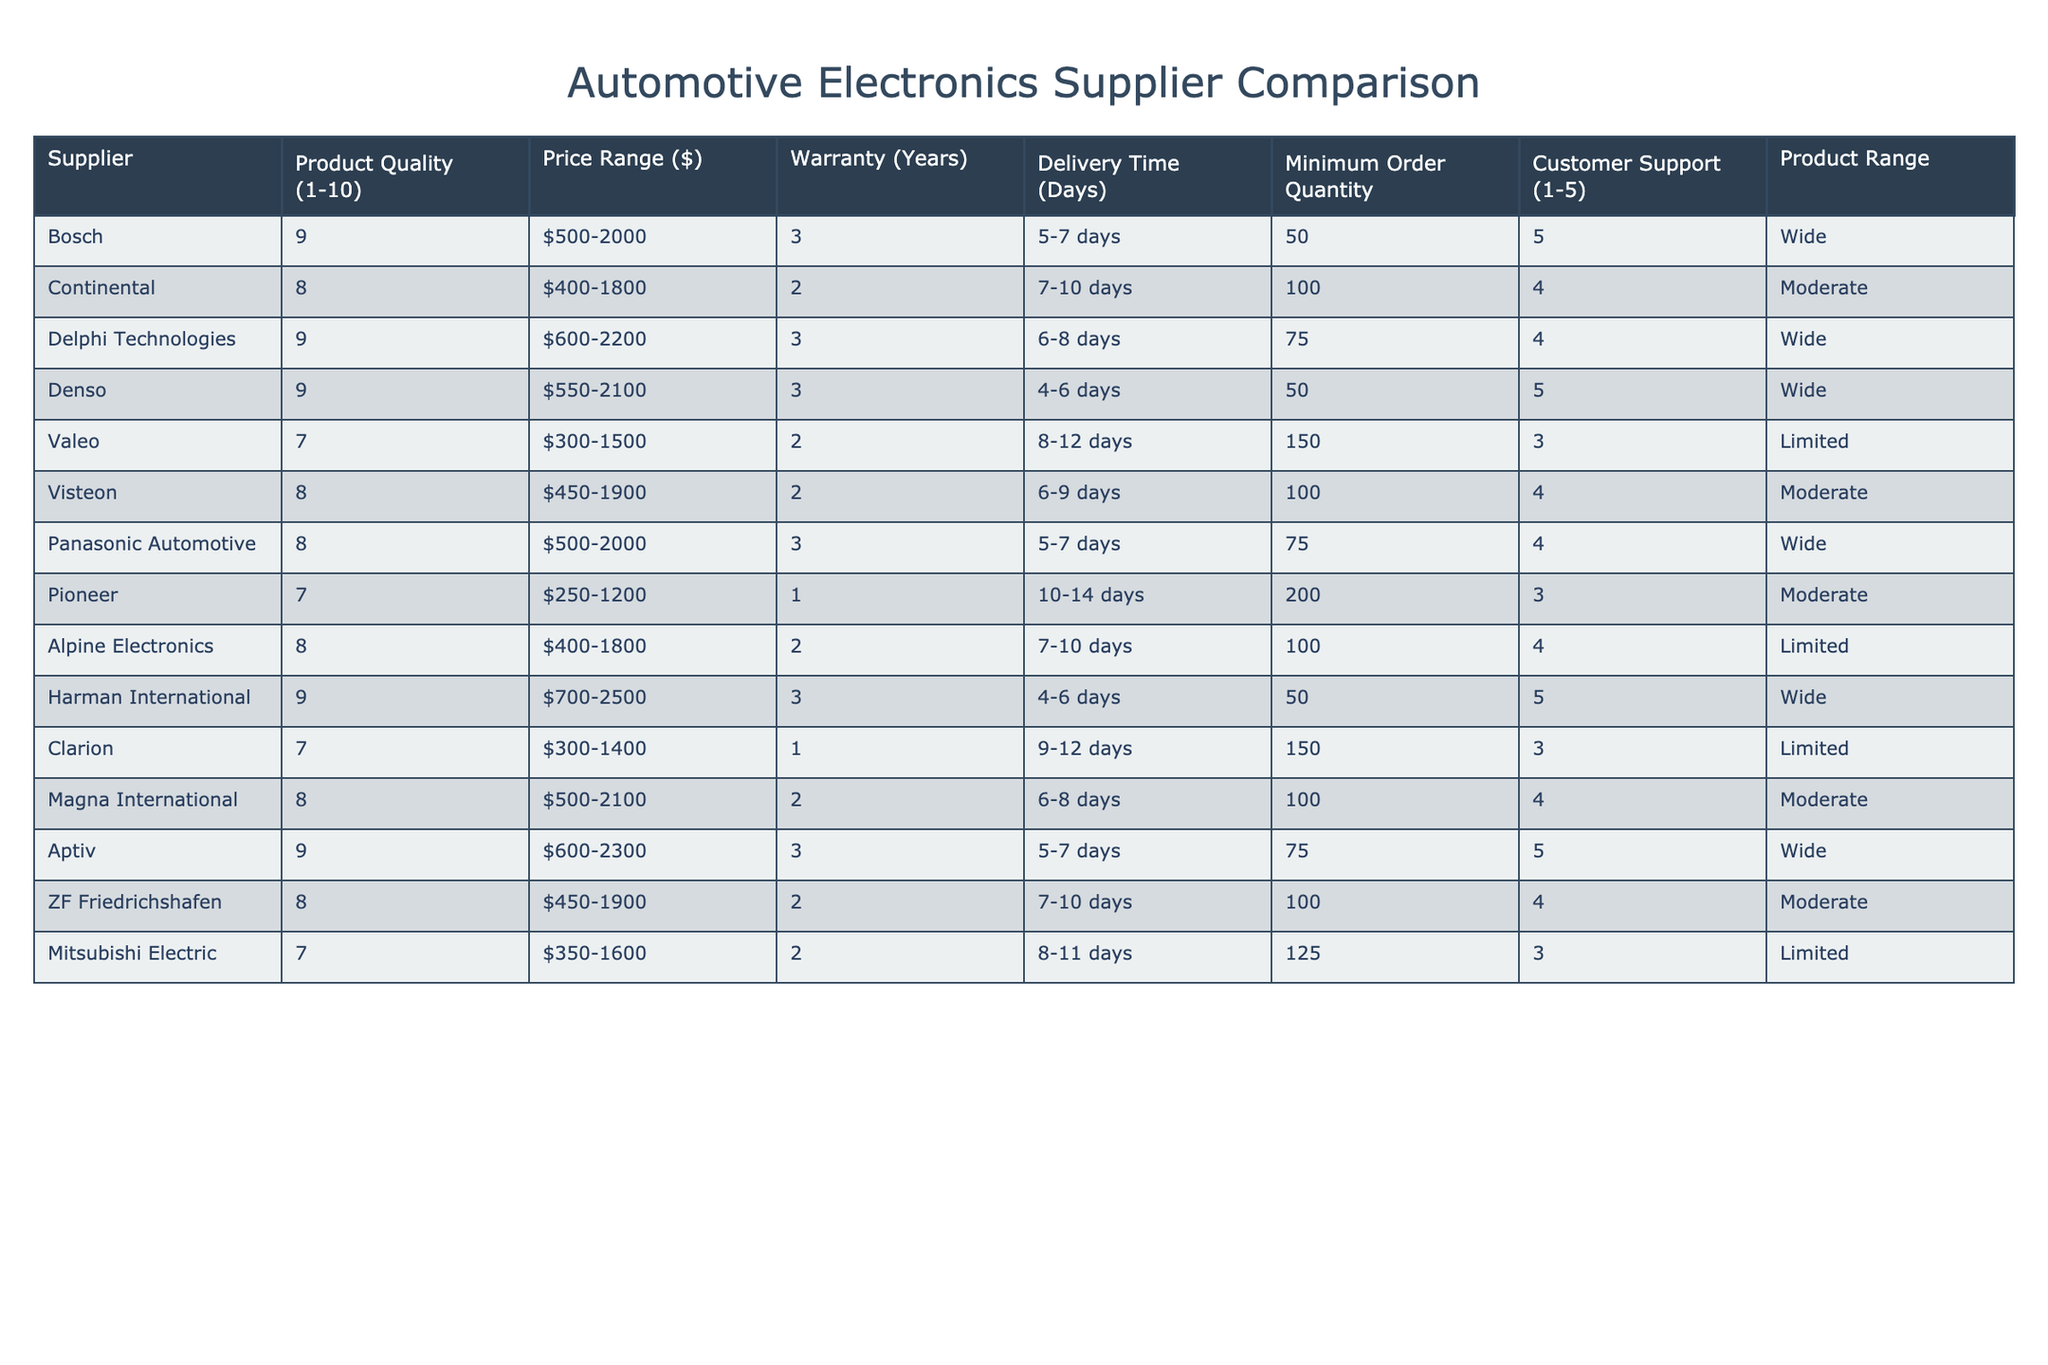What is the highest product quality rating among the suppliers? Looking at the "Product Quality (1-10)" column, the highest rating recorded is 9, which appears for Bosch, Delphi Technologies, Denso, Harman International, and Aptiv.
Answer: 9 Which supplier offers the lowest warranty period? Checking the "Warranty (Years)" column, the lowest warranty is provided by Pioneer and Clarion, both with a period of 1 year.
Answer: Pioneer and Clarion What is the average price range of the suppliers? To find the average price range, we calculate the midpoint of each supplier's range: (500+2000)/2, (400+1800)/2, etc. Summing these up gives 1167.5, and dividing by 12 suppliers yields an average of approximately 972.92.
Answer: 972.92 Which supplier has the quickest delivery time? Comparing the "Delivery Time (Days)" for each supplier, Denso has the quickest average delivery time with 4-6 days, which implies a range of about 5 days.
Answer: 5 days Does any supplier have a product range labeled as 'Limited'? By reviewing the "Product Range" column, we find that Valeo, Pioneer, Alpine Electronics, Clarion, and Mitsubishi Electric all have a product range labeled as 'Limited'.
Answer: Yes What is the total minimum order quantity of all the suppliers combined? Summing the "Minimum Order Quantity" for each supplier gives a total of 1210 (50 + 100 + 75 + 50 + 150 + 100 + 75 + 200 + 100 + 100 + 125 + 150).
Answer: 1210 Is there a supplier with a product quality rating below 7? Looking closely at the "Product Quality (1-10)" column, Valeo, Pioneer, Clarion, and Mitsubishi Electric have ratings of 7 or below, confirming that there are suppliers with lower quality ratings.
Answer: Yes 